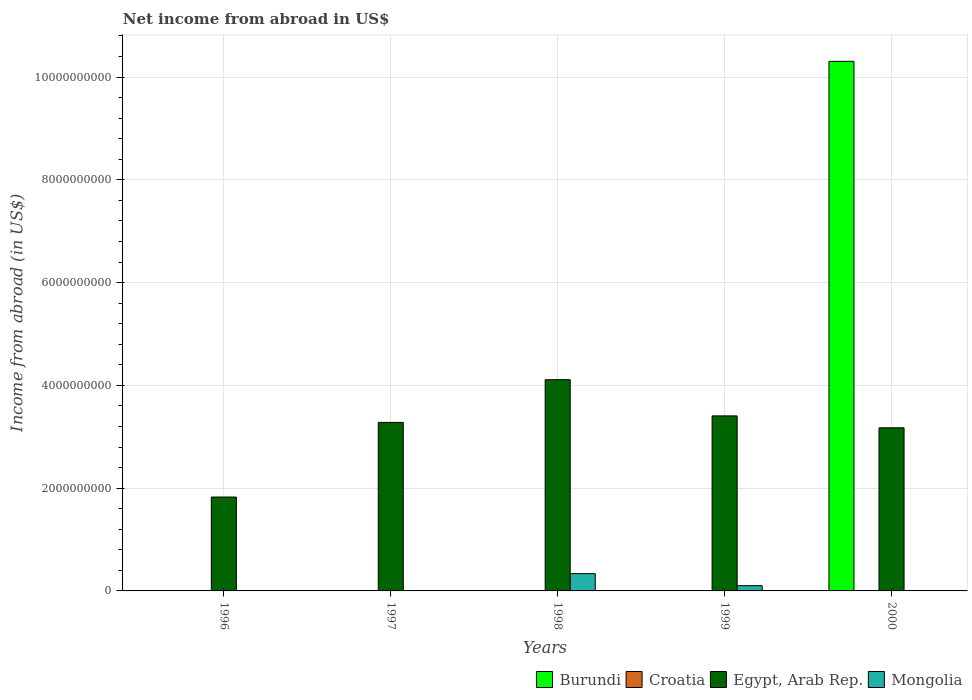How many different coloured bars are there?
Your response must be concise. 3. Are the number of bars per tick equal to the number of legend labels?
Your answer should be very brief. No. How many bars are there on the 2nd tick from the right?
Keep it short and to the point. 2. Across all years, what is the maximum net income from abroad in Mongolia?
Give a very brief answer. 3.36e+08. Across all years, what is the minimum net income from abroad in Mongolia?
Your answer should be very brief. 0. In which year was the net income from abroad in Burundi maximum?
Your answer should be very brief. 2000. What is the total net income from abroad in Burundi in the graph?
Make the answer very short. 1.03e+1. What is the difference between the net income from abroad in Egypt, Arab Rep. in 1996 and that in 1998?
Your answer should be very brief. -2.28e+09. What is the difference between the net income from abroad in Croatia in 1997 and the net income from abroad in Mongolia in 1999?
Offer a terse response. -1.02e+08. What is the ratio of the net income from abroad in Egypt, Arab Rep. in 1996 to that in 1997?
Make the answer very short. 0.56. What is the difference between the highest and the second highest net income from abroad in Egypt, Arab Rep.?
Provide a short and direct response. 7.05e+08. What is the difference between the highest and the lowest net income from abroad in Egypt, Arab Rep.?
Provide a short and direct response. 2.28e+09. In how many years, is the net income from abroad in Egypt, Arab Rep. greater than the average net income from abroad in Egypt, Arab Rep. taken over all years?
Your answer should be compact. 4. What is the difference between two consecutive major ticks on the Y-axis?
Offer a terse response. 2.00e+09. Does the graph contain grids?
Provide a short and direct response. Yes. What is the title of the graph?
Provide a succinct answer. Net income from abroad in US$. What is the label or title of the X-axis?
Offer a very short reply. Years. What is the label or title of the Y-axis?
Offer a very short reply. Income from abroad (in US$). What is the Income from abroad (in US$) of Burundi in 1996?
Your answer should be very brief. 0. What is the Income from abroad (in US$) of Croatia in 1996?
Ensure brevity in your answer.  0. What is the Income from abroad (in US$) of Egypt, Arab Rep. in 1996?
Give a very brief answer. 1.83e+09. What is the Income from abroad (in US$) in Croatia in 1997?
Provide a succinct answer. 0. What is the Income from abroad (in US$) of Egypt, Arab Rep. in 1997?
Provide a short and direct response. 3.28e+09. What is the Income from abroad (in US$) in Egypt, Arab Rep. in 1998?
Your answer should be very brief. 4.11e+09. What is the Income from abroad (in US$) of Mongolia in 1998?
Your answer should be very brief. 3.36e+08. What is the Income from abroad (in US$) of Egypt, Arab Rep. in 1999?
Offer a very short reply. 3.41e+09. What is the Income from abroad (in US$) in Mongolia in 1999?
Offer a terse response. 1.02e+08. What is the Income from abroad (in US$) of Burundi in 2000?
Offer a very short reply. 1.03e+1. What is the Income from abroad (in US$) of Egypt, Arab Rep. in 2000?
Your response must be concise. 3.17e+09. Across all years, what is the maximum Income from abroad (in US$) of Burundi?
Keep it short and to the point. 1.03e+1. Across all years, what is the maximum Income from abroad (in US$) in Egypt, Arab Rep.?
Give a very brief answer. 4.11e+09. Across all years, what is the maximum Income from abroad (in US$) in Mongolia?
Offer a terse response. 3.36e+08. Across all years, what is the minimum Income from abroad (in US$) of Burundi?
Ensure brevity in your answer.  0. Across all years, what is the minimum Income from abroad (in US$) of Egypt, Arab Rep.?
Provide a short and direct response. 1.83e+09. What is the total Income from abroad (in US$) in Burundi in the graph?
Keep it short and to the point. 1.03e+1. What is the total Income from abroad (in US$) of Croatia in the graph?
Your answer should be compact. 0. What is the total Income from abroad (in US$) of Egypt, Arab Rep. in the graph?
Your answer should be very brief. 1.58e+1. What is the total Income from abroad (in US$) in Mongolia in the graph?
Your answer should be very brief. 4.38e+08. What is the difference between the Income from abroad (in US$) in Egypt, Arab Rep. in 1996 and that in 1997?
Ensure brevity in your answer.  -1.45e+09. What is the difference between the Income from abroad (in US$) of Egypt, Arab Rep. in 1996 and that in 1998?
Provide a short and direct response. -2.28e+09. What is the difference between the Income from abroad (in US$) of Egypt, Arab Rep. in 1996 and that in 1999?
Keep it short and to the point. -1.58e+09. What is the difference between the Income from abroad (in US$) of Egypt, Arab Rep. in 1996 and that in 2000?
Offer a very short reply. -1.35e+09. What is the difference between the Income from abroad (in US$) of Egypt, Arab Rep. in 1997 and that in 1998?
Give a very brief answer. -8.32e+08. What is the difference between the Income from abroad (in US$) of Egypt, Arab Rep. in 1997 and that in 1999?
Provide a short and direct response. -1.27e+08. What is the difference between the Income from abroad (in US$) in Egypt, Arab Rep. in 1997 and that in 2000?
Your response must be concise. 1.05e+08. What is the difference between the Income from abroad (in US$) of Egypt, Arab Rep. in 1998 and that in 1999?
Your response must be concise. 7.05e+08. What is the difference between the Income from abroad (in US$) in Mongolia in 1998 and that in 1999?
Give a very brief answer. 2.34e+08. What is the difference between the Income from abroad (in US$) in Egypt, Arab Rep. in 1998 and that in 2000?
Ensure brevity in your answer.  9.36e+08. What is the difference between the Income from abroad (in US$) of Egypt, Arab Rep. in 1999 and that in 2000?
Make the answer very short. 2.32e+08. What is the difference between the Income from abroad (in US$) of Egypt, Arab Rep. in 1996 and the Income from abroad (in US$) of Mongolia in 1998?
Offer a very short reply. 1.49e+09. What is the difference between the Income from abroad (in US$) in Egypt, Arab Rep. in 1996 and the Income from abroad (in US$) in Mongolia in 1999?
Ensure brevity in your answer.  1.72e+09. What is the difference between the Income from abroad (in US$) of Egypt, Arab Rep. in 1997 and the Income from abroad (in US$) of Mongolia in 1998?
Offer a very short reply. 2.94e+09. What is the difference between the Income from abroad (in US$) of Egypt, Arab Rep. in 1997 and the Income from abroad (in US$) of Mongolia in 1999?
Give a very brief answer. 3.18e+09. What is the difference between the Income from abroad (in US$) of Egypt, Arab Rep. in 1998 and the Income from abroad (in US$) of Mongolia in 1999?
Ensure brevity in your answer.  4.01e+09. What is the average Income from abroad (in US$) of Burundi per year?
Your response must be concise. 2.06e+09. What is the average Income from abroad (in US$) of Croatia per year?
Your answer should be compact. 0. What is the average Income from abroad (in US$) of Egypt, Arab Rep. per year?
Your answer should be compact. 3.16e+09. What is the average Income from abroad (in US$) of Mongolia per year?
Give a very brief answer. 8.76e+07. In the year 1998, what is the difference between the Income from abroad (in US$) of Egypt, Arab Rep. and Income from abroad (in US$) of Mongolia?
Ensure brevity in your answer.  3.77e+09. In the year 1999, what is the difference between the Income from abroad (in US$) of Egypt, Arab Rep. and Income from abroad (in US$) of Mongolia?
Offer a terse response. 3.30e+09. In the year 2000, what is the difference between the Income from abroad (in US$) of Burundi and Income from abroad (in US$) of Egypt, Arab Rep.?
Your answer should be compact. 7.13e+09. What is the ratio of the Income from abroad (in US$) in Egypt, Arab Rep. in 1996 to that in 1997?
Offer a terse response. 0.56. What is the ratio of the Income from abroad (in US$) in Egypt, Arab Rep. in 1996 to that in 1998?
Your response must be concise. 0.44. What is the ratio of the Income from abroad (in US$) in Egypt, Arab Rep. in 1996 to that in 1999?
Ensure brevity in your answer.  0.54. What is the ratio of the Income from abroad (in US$) of Egypt, Arab Rep. in 1996 to that in 2000?
Your answer should be very brief. 0.58. What is the ratio of the Income from abroad (in US$) of Egypt, Arab Rep. in 1997 to that in 1998?
Provide a short and direct response. 0.8. What is the ratio of the Income from abroad (in US$) of Egypt, Arab Rep. in 1997 to that in 1999?
Provide a short and direct response. 0.96. What is the ratio of the Income from abroad (in US$) in Egypt, Arab Rep. in 1997 to that in 2000?
Your answer should be very brief. 1.03. What is the ratio of the Income from abroad (in US$) in Egypt, Arab Rep. in 1998 to that in 1999?
Offer a very short reply. 1.21. What is the ratio of the Income from abroad (in US$) of Mongolia in 1998 to that in 1999?
Your response must be concise. 3.29. What is the ratio of the Income from abroad (in US$) of Egypt, Arab Rep. in 1998 to that in 2000?
Your answer should be compact. 1.29. What is the ratio of the Income from abroad (in US$) of Egypt, Arab Rep. in 1999 to that in 2000?
Offer a terse response. 1.07. What is the difference between the highest and the second highest Income from abroad (in US$) in Egypt, Arab Rep.?
Your answer should be compact. 7.05e+08. What is the difference between the highest and the lowest Income from abroad (in US$) of Burundi?
Make the answer very short. 1.03e+1. What is the difference between the highest and the lowest Income from abroad (in US$) of Egypt, Arab Rep.?
Your answer should be very brief. 2.28e+09. What is the difference between the highest and the lowest Income from abroad (in US$) in Mongolia?
Your answer should be very brief. 3.36e+08. 